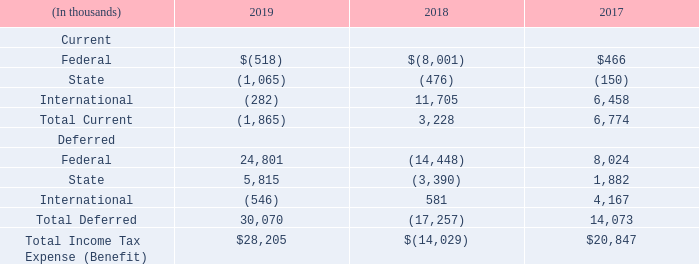Note 13 – Income Taxes
A summary of the components of the expense (benefit) for income taxes for the years ended December 31, 2019, 2018 and 2017 is as follows:
Which periods are included in the summary of the components of the expense (benefit) for income taxes in the table? The years ended december 31, 2019, 2018 and 2017. What was the expense (benefit) of the current Federal component in 2019?
Answer scale should be: thousand. $(518). What is the expense (benefit) for current International component?
Answer scale should be: thousand. (282). What was the change in current state expense (benefit) between 2018 and 2019?
Answer scale should be: thousand. -1,065-(-476)
Answer: -589. What was the change in deferred federal expense (benefit) between 2018 and 2019?
Answer scale should be: thousand. 24,801-(-14,448)
Answer: 39249. What is the percentage change in total income tax expense (benefit) between 2018 and 2019?
Answer scale should be: percent. ($28,205-(-$14,029))/-$14,029
Answer: -301.05. 